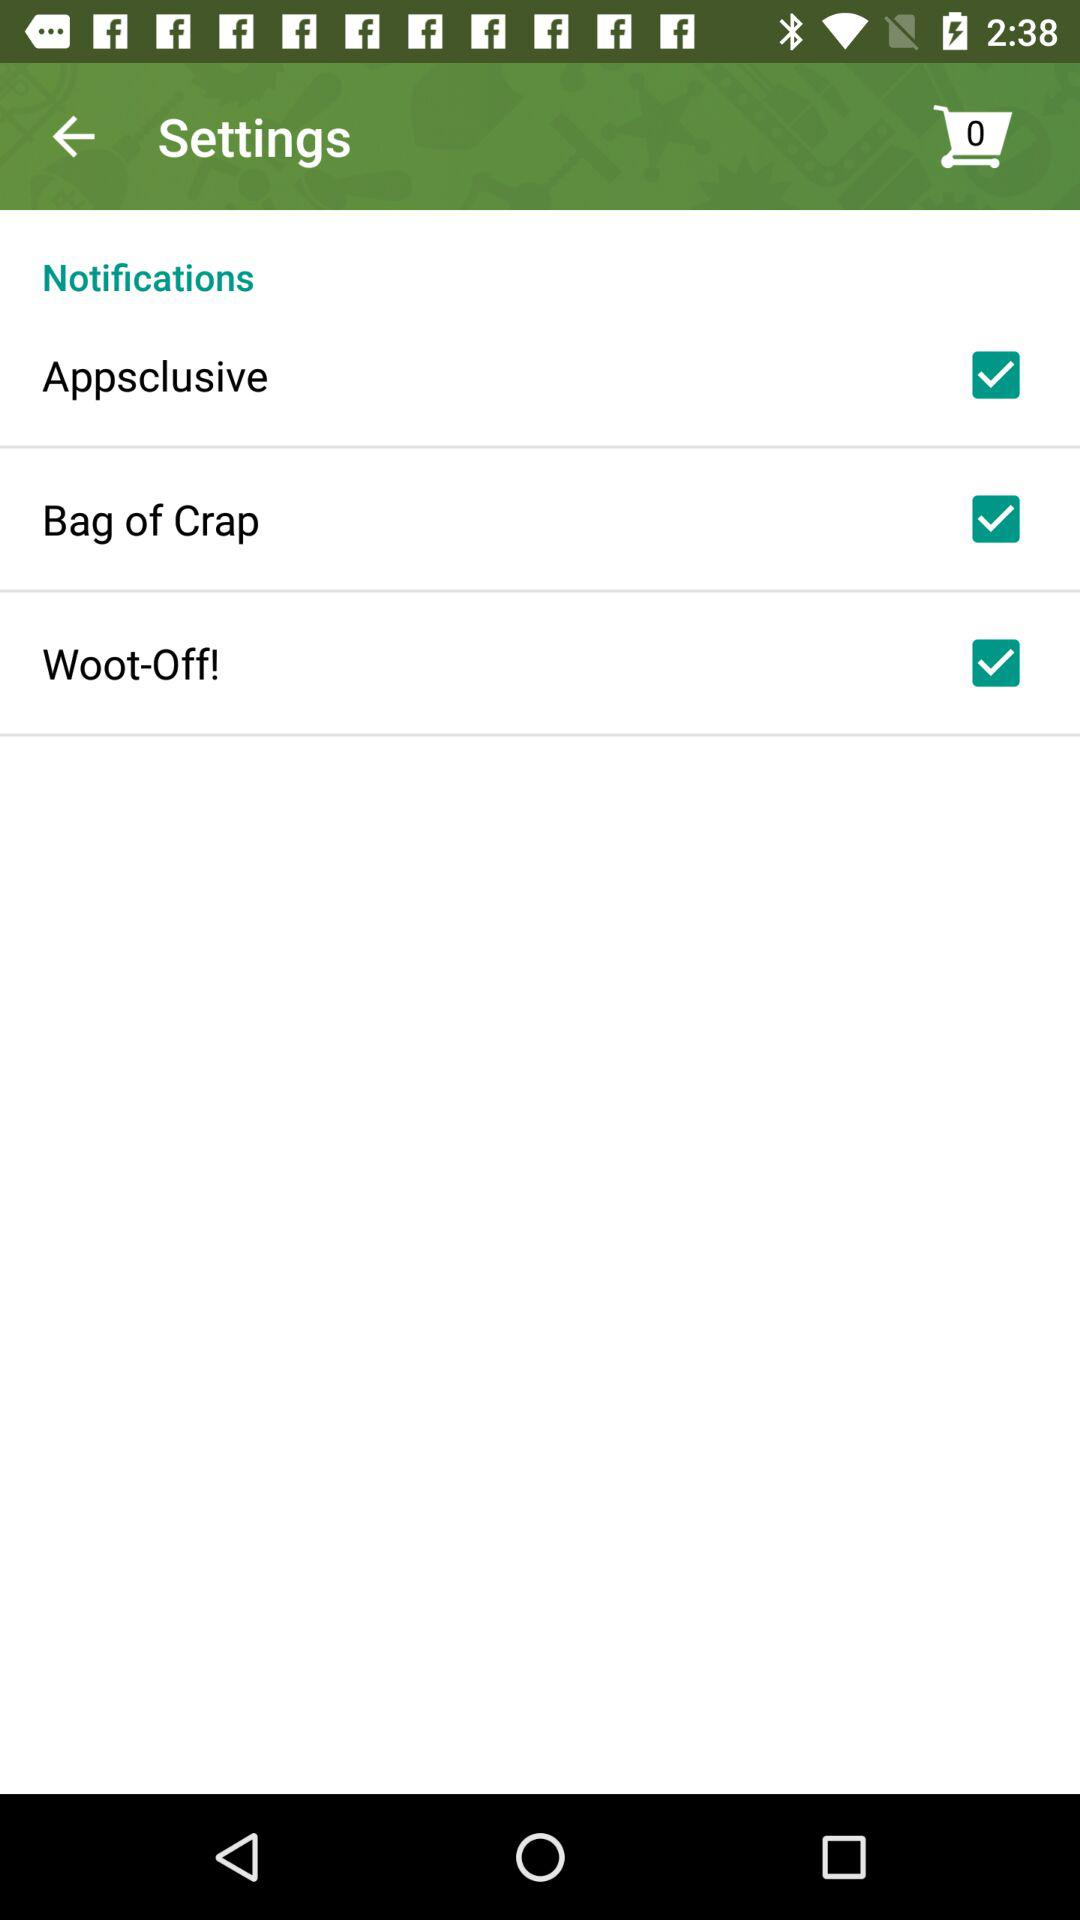What is the status of the bag of crap? The status is on. 